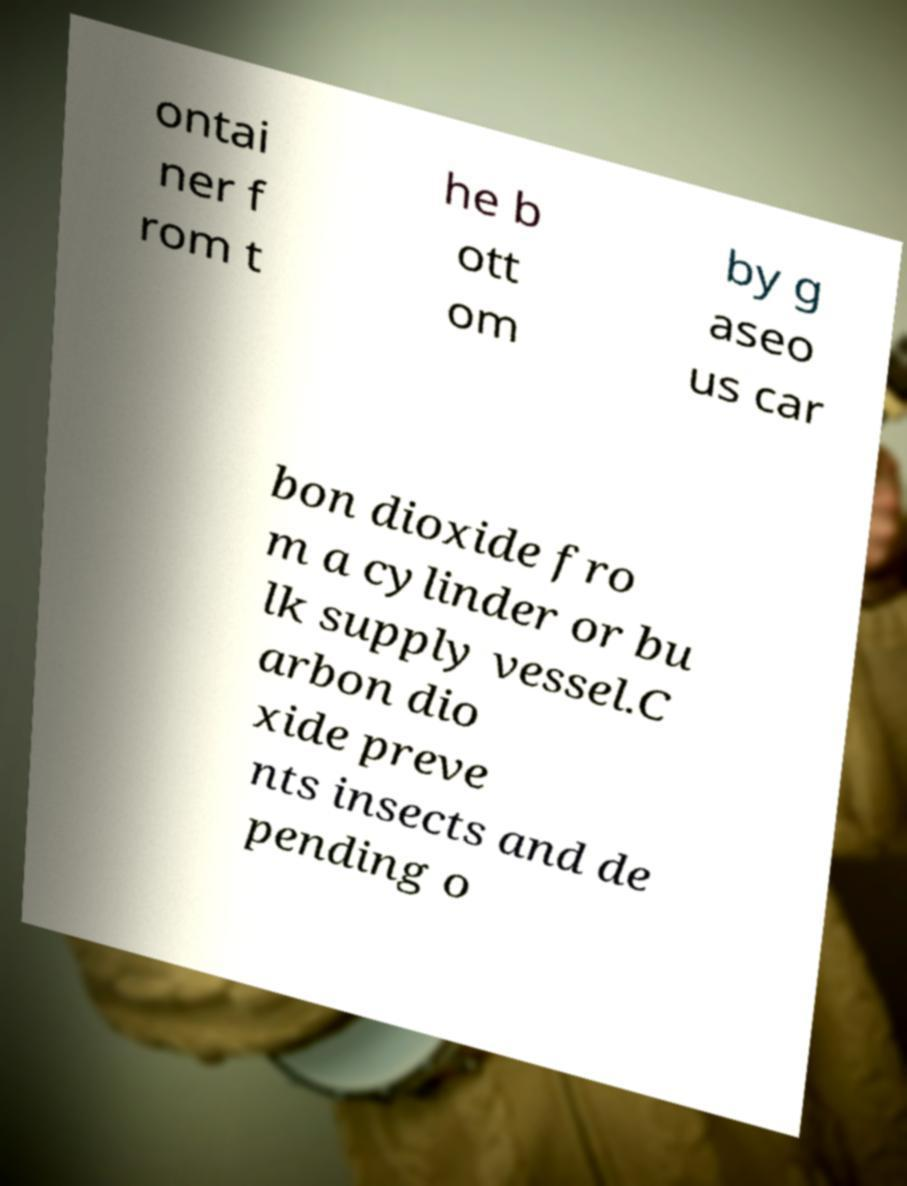Could you assist in decoding the text presented in this image and type it out clearly? ontai ner f rom t he b ott om by g aseo us car bon dioxide fro m a cylinder or bu lk supply vessel.C arbon dio xide preve nts insects and de pending o 